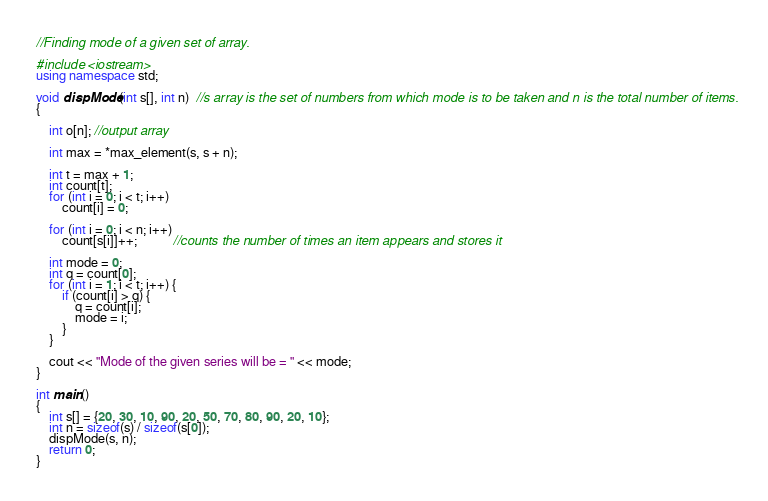Convert code to text. <code><loc_0><loc_0><loc_500><loc_500><_C++_>//Finding mode of a given set of array.

#include <iostream> 
using namespace std; 
  
void dispMode(int s[], int n)  //s array is the set of numbers from which mode is to be taken and n is the total number of items.
{ 
    
    int o[n]; //output array
  
    int max = *max_element(s, s + n); 
   
    int t = max + 1; 
    int count[t]; 
    for (int i = 0; i < t; i++) 
        count[i] = 0; 
  
    for (int i = 0; i < n; i++) 
        count[s[i]]++;           //counts the number of times an item appears and stores it
  
    int mode = 0; 
    int q = count[0]; 
    for (int i = 1; i < t; i++) { 
        if (count[i] > q) { 
            q = count[i]; 
            mode = i; 
        } 
    } 
  
    cout << "Mode of the given series will be = " << mode; 
} 
  
int main() 
{ 
    int s[] = {20, 30, 10, 90, 20, 50, 70, 80, 90, 20, 10}; 
    int n = sizeof(s) / sizeof(s[0]); 
    dispMode(s, n); 
    return 0; 
} </code> 